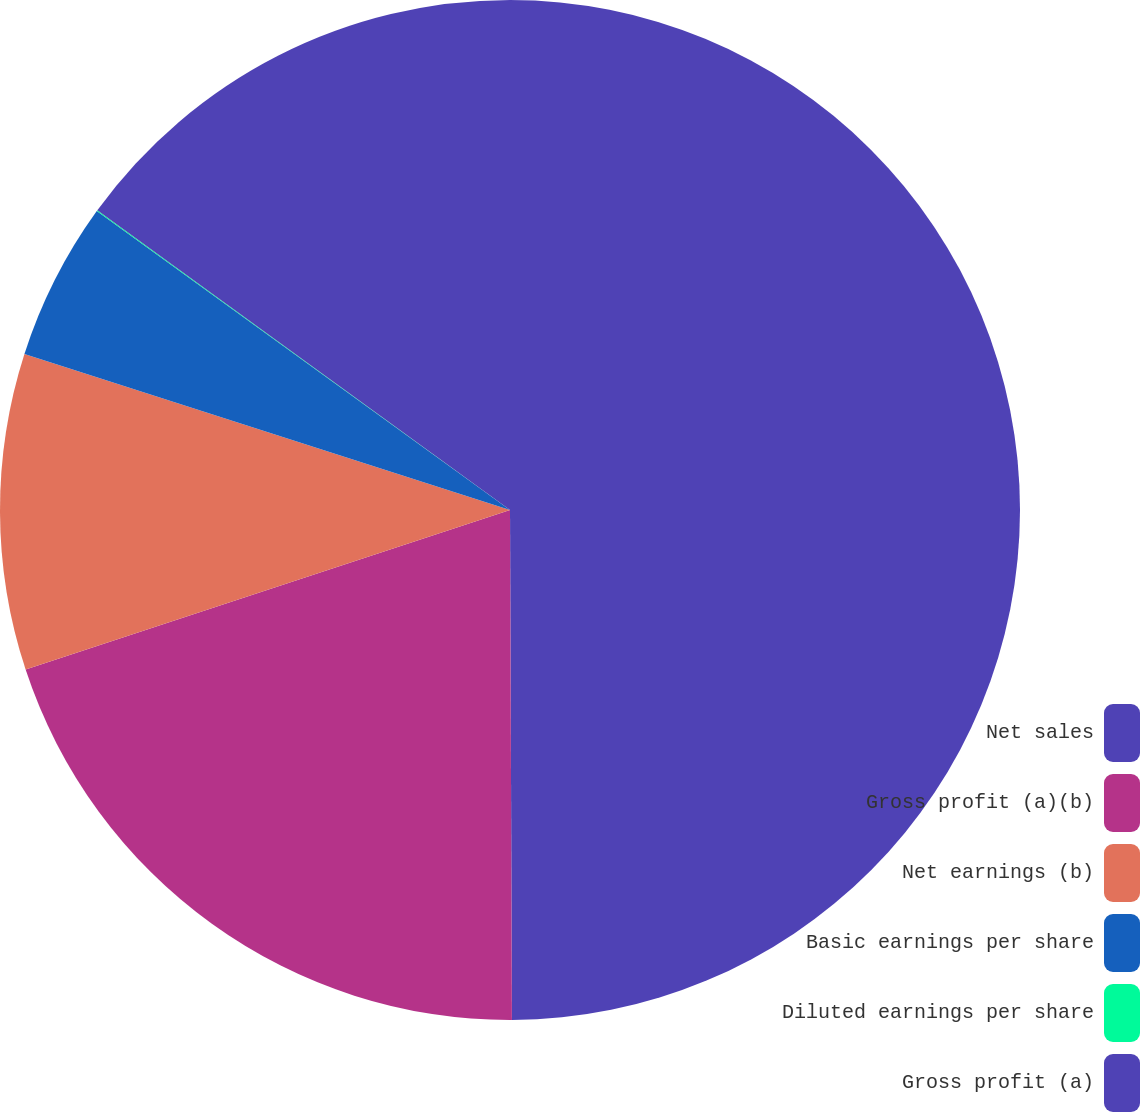Convert chart. <chart><loc_0><loc_0><loc_500><loc_500><pie_chart><fcel>Net sales<fcel>Gross profit (a)(b)<fcel>Net earnings (b)<fcel>Basic earnings per share<fcel>Diluted earnings per share<fcel>Gross profit (a)<nl><fcel>49.93%<fcel>19.99%<fcel>10.01%<fcel>5.02%<fcel>0.03%<fcel>15.0%<nl></chart> 